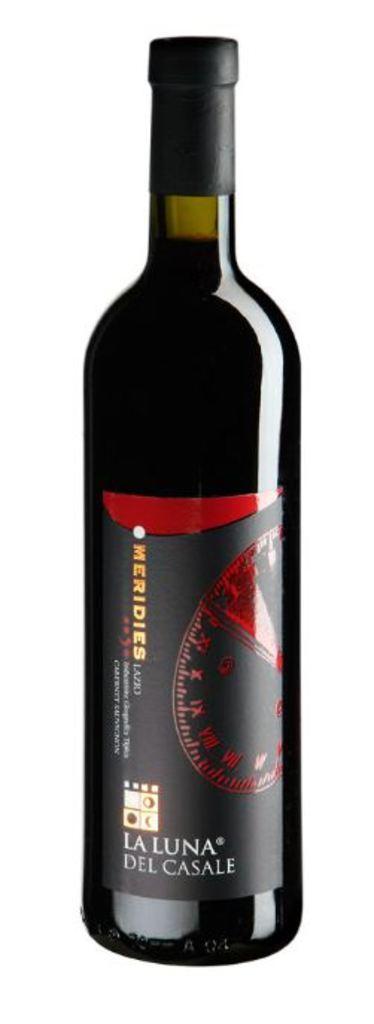How would you summarize this image in a sentence or two? In this given picture there is a wine bottle here. 